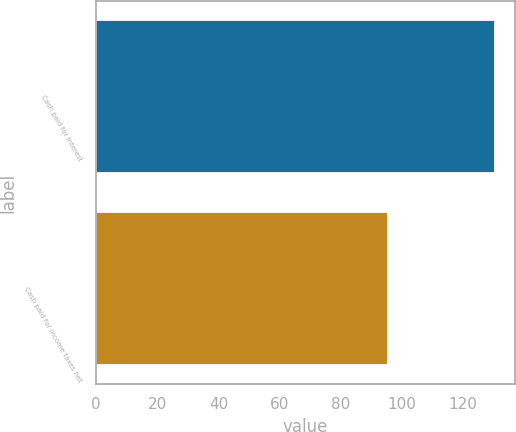Convert chart to OTSL. <chart><loc_0><loc_0><loc_500><loc_500><bar_chart><fcel>Cash paid for interest<fcel>Cash paid for income taxes net<nl><fcel>130.6<fcel>95.7<nl></chart> 